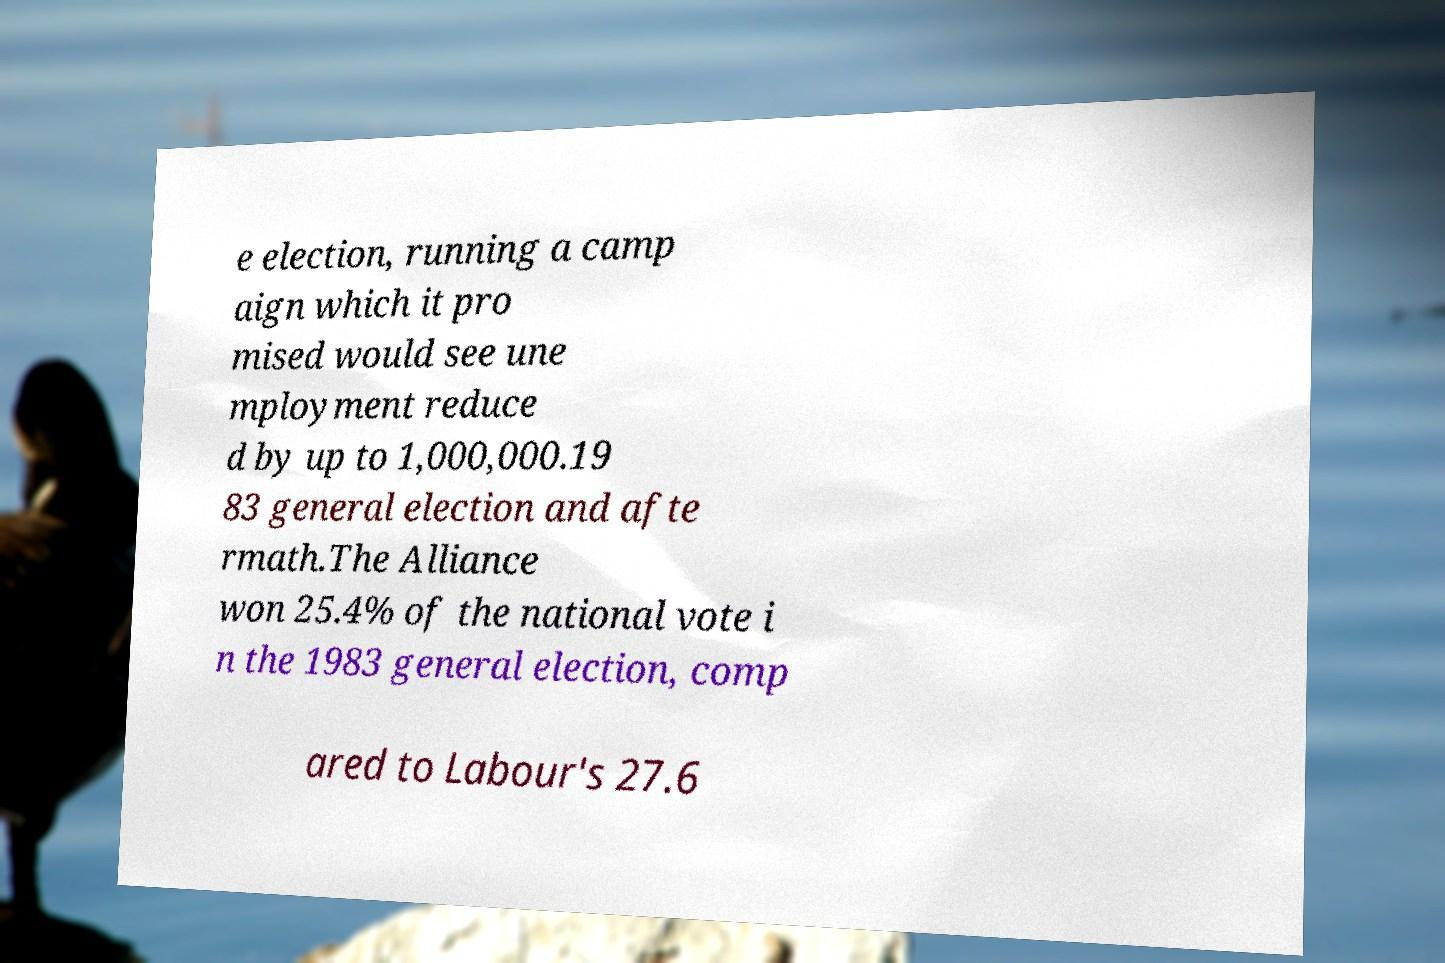Please read and relay the text visible in this image. What does it say? e election, running a camp aign which it pro mised would see une mployment reduce d by up to 1,000,000.19 83 general election and afte rmath.The Alliance won 25.4% of the national vote i n the 1983 general election, comp ared to Labour's 27.6 